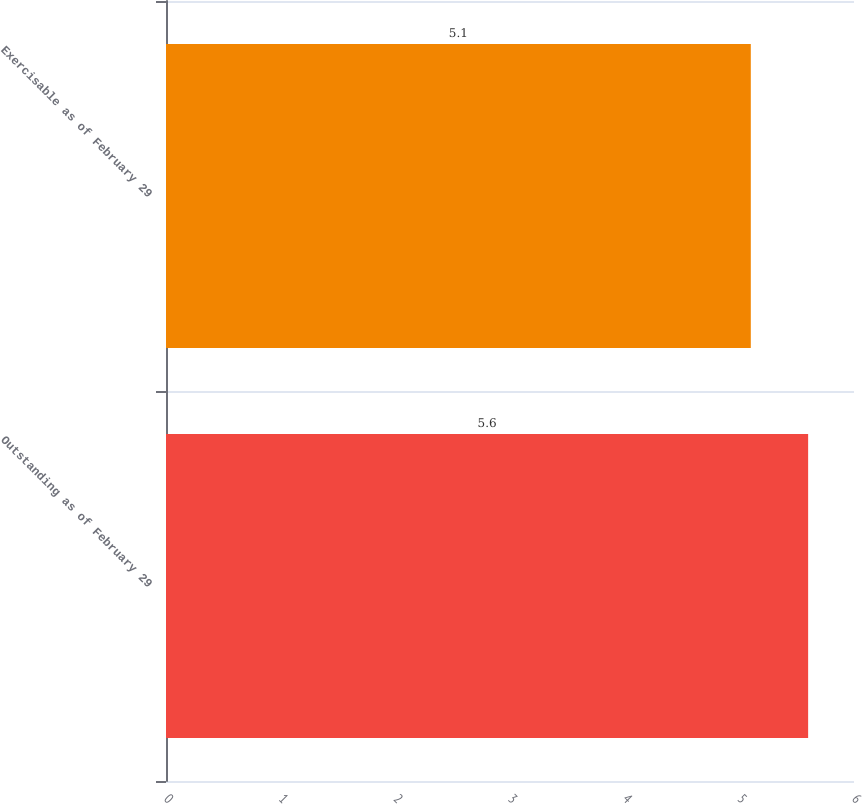Convert chart. <chart><loc_0><loc_0><loc_500><loc_500><bar_chart><fcel>Outstanding as of February 29<fcel>Exercisable as of February 29<nl><fcel>5.6<fcel>5.1<nl></chart> 